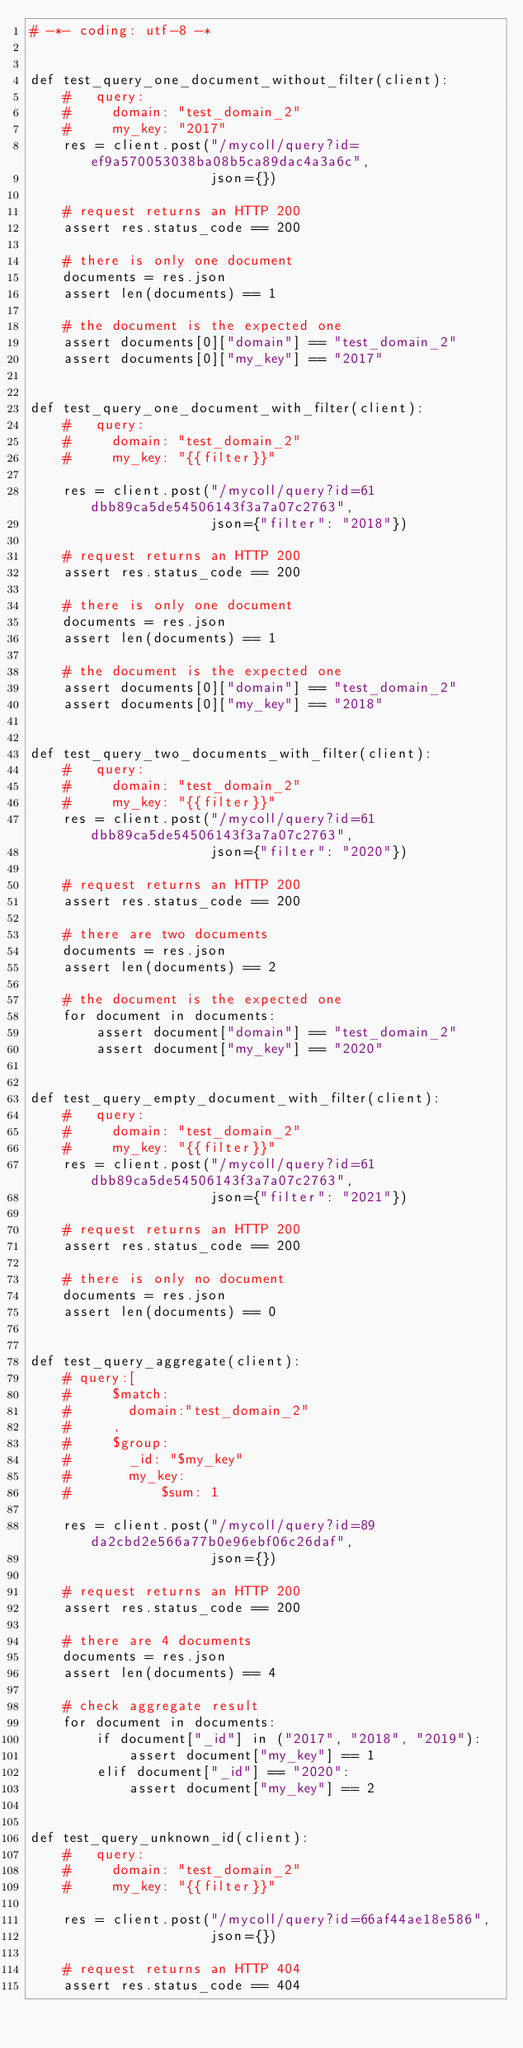Convert code to text. <code><loc_0><loc_0><loc_500><loc_500><_Python_># -*- coding: utf-8 -*


def test_query_one_document_without_filter(client):
    #   query:
    #     domain: "test_domain_2"
    #     my_key: "2017"
    res = client.post("/mycoll/query?id=ef9a570053038ba08b5ca89dac4a3a6c",
                      json={})

    # request returns an HTTP 200
    assert res.status_code == 200

    # there is only one document
    documents = res.json
    assert len(documents) == 1

    # the document is the expected one
    assert documents[0]["domain"] == "test_domain_2"
    assert documents[0]["my_key"] == "2017"


def test_query_one_document_with_filter(client):
    #   query:
    #     domain: "test_domain_2"
    #     my_key: "{{filter}}"

    res = client.post("/mycoll/query?id=61dbb89ca5de54506143f3a7a07c2763",
                      json={"filter": "2018"})

    # request returns an HTTP 200
    assert res.status_code == 200

    # there is only one document
    documents = res.json
    assert len(documents) == 1

    # the document is the expected one
    assert documents[0]["domain"] == "test_domain_2"
    assert documents[0]["my_key"] == "2018"


def test_query_two_documents_with_filter(client):
    #   query:
    #     domain: "test_domain_2"
    #     my_key: "{{filter}}"
    res = client.post("/mycoll/query?id=61dbb89ca5de54506143f3a7a07c2763",
                      json={"filter": "2020"})

    # request returns an HTTP 200
    assert res.status_code == 200

    # there are two documents
    documents = res.json
    assert len(documents) == 2

    # the document is the expected one
    for document in documents:
        assert document["domain"] == "test_domain_2"
        assert document["my_key"] == "2020"


def test_query_empty_document_with_filter(client):
    #   query:
    #     domain: "test_domain_2"
    #     my_key: "{{filter}}"
    res = client.post("/mycoll/query?id=61dbb89ca5de54506143f3a7a07c2763",
                      json={"filter": "2021"})

    # request returns an HTTP 200
    assert res.status_code == 200

    # there is only no document
    documents = res.json
    assert len(documents) == 0


def test_query_aggregate(client):
    # query:[
    #     $match:
    #       domain:"test_domain_2"
    #     ,
    #     $group:
    #       _id: "$my_key"
    #       my_key:
    #           $sum: 1

    res = client.post("/mycoll/query?id=89da2cbd2e566a77b0e96ebf06c26daf",
                      json={})

    # request returns an HTTP 200
    assert res.status_code == 200

    # there are 4 documents
    documents = res.json
    assert len(documents) == 4

    # check aggregate result
    for document in documents:
        if document["_id"] in ("2017", "2018", "2019"):
            assert document["my_key"] == 1
        elif document["_id"] == "2020":
            assert document["my_key"] == 2


def test_query_unknown_id(client):
    #   query:
    #     domain: "test_domain_2"
    #     my_key: "{{filter}}"

    res = client.post("/mycoll/query?id=66af44ae18e586",
                      json={})

    # request returns an HTTP 404
    assert res.status_code == 404
</code> 